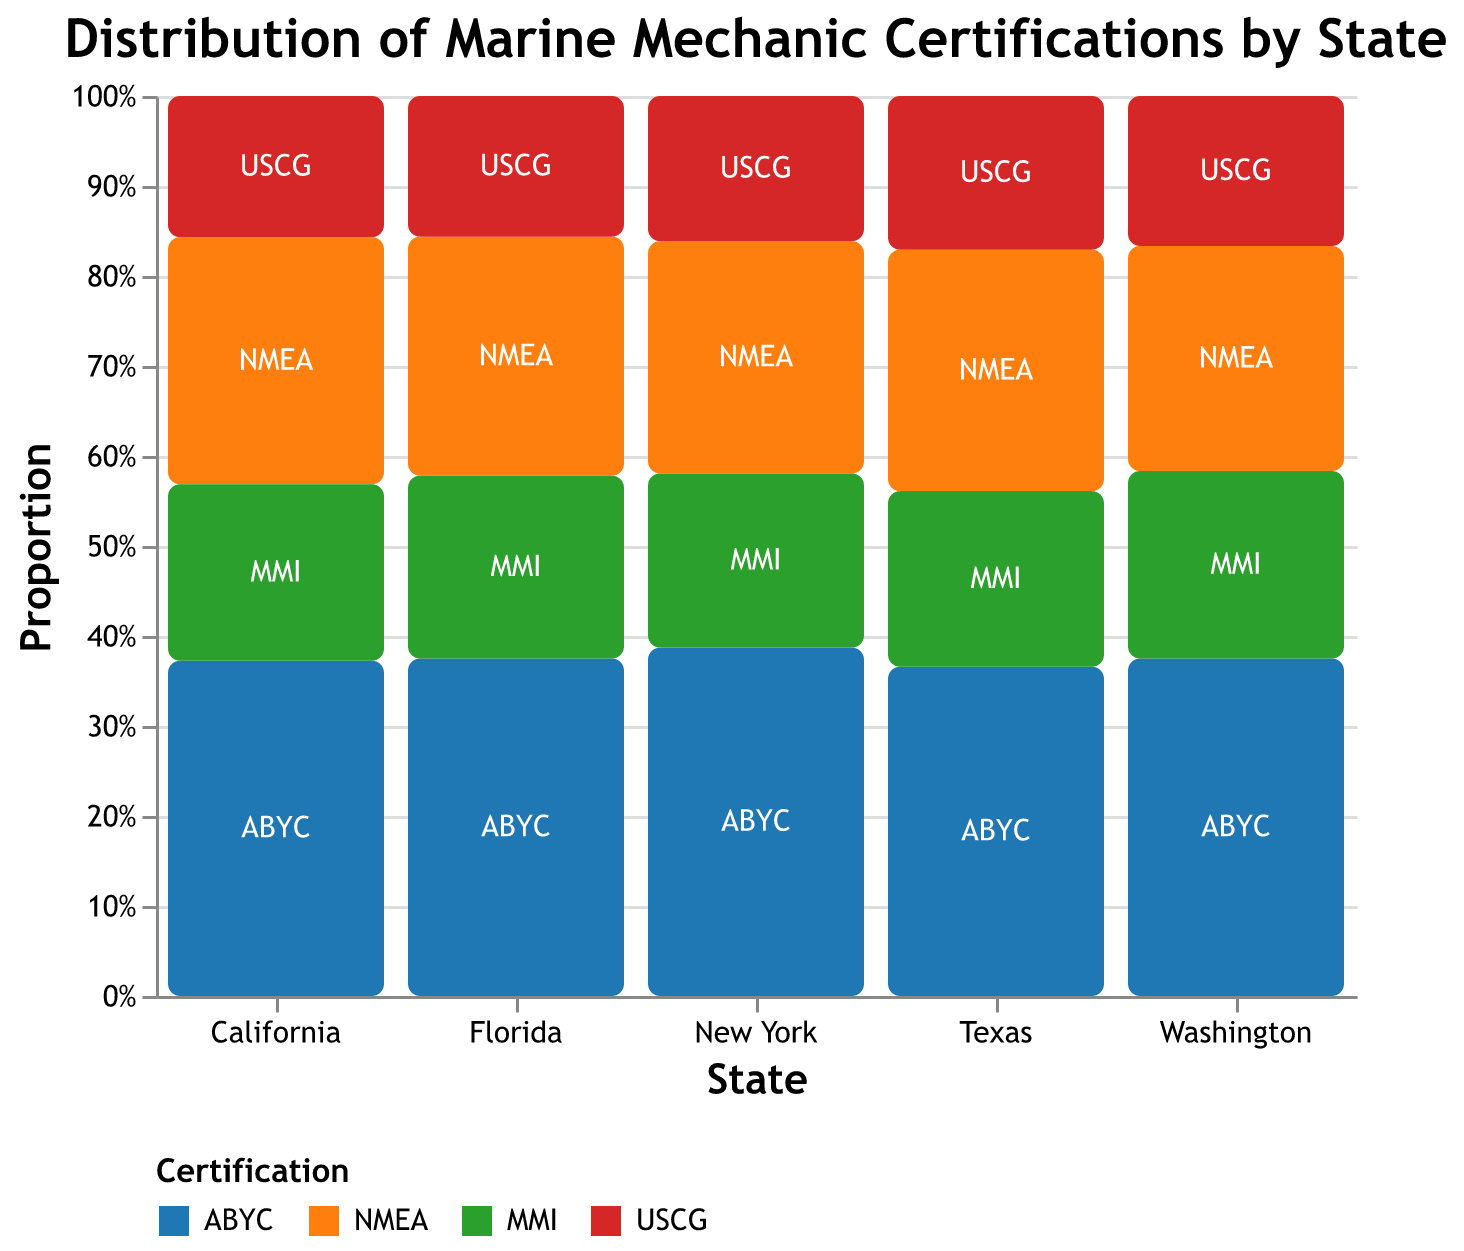What is the title of the chart? The title is usually located at the top center of the plot and provides an overview of the data being visualized.
Answer: Distribution of Marine Mechanic Certifications by State Which state has the highest number of ABYC certified marine mechanics? Look at the segments for ABYC certification in each state and compare the heights. The tallest segment corresponds to the highest count.
Answer: Florida What is the total number of USCG certified marine mechanics in California and Texas combined? Add the counts for USCG certification in both California and Texas.
Answer: 40 (California) + 35 (Texas) = 75 Which certification has the smallest representation in Washington? Compare the heights of different certification segments in the state of Washington. The smallest segment represents the certification with the fewest count.
Answer: USCG How do the proportions of ABYC certifications compare between Florida and New York? Compare the height of the ABYC segments in both Florida and New York. Florida's ABYC segment is taller than New York's.
Answer: Florida is higher than New York Which state has the most balanced distribution of certifications? Look for the state where all certification segments are of relatively equal height. This means that no certification vastly outnumbers the others.
Answer: Washington How do the total counts of NMEA certified mechanics compare between Florida and California? Look at the NMEA segment heights in both states and compare their values.
Answer: Florida has more than California What is the total number of marine mechanics (all certifications combined) in Texas? Sum the counts for all certifications in Texas from the plot.
Answer: 75 (ABYC) + 55 (NMEA) + 40 (MMI) + 35 (USCG) = 205 Which certification is the most popular overall? Add the counts of all states for each certification and compare the totals.
Answer: ABYC What percentage of New York's marine mechanics have MMI certification? Find the MMI segment in New York and calculate its percentage relative to the total number of New York's marine mechanics.
Answer: (30 / (60 + 40 + 30 + 25)) * 100 = 20% 